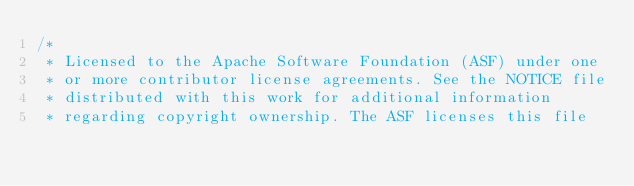<code> <loc_0><loc_0><loc_500><loc_500><_C++_>/*
 * Licensed to the Apache Software Foundation (ASF) under one
 * or more contributor license agreements. See the NOTICE file
 * distributed with this work for additional information
 * regarding copyright ownership. The ASF licenses this file</code> 